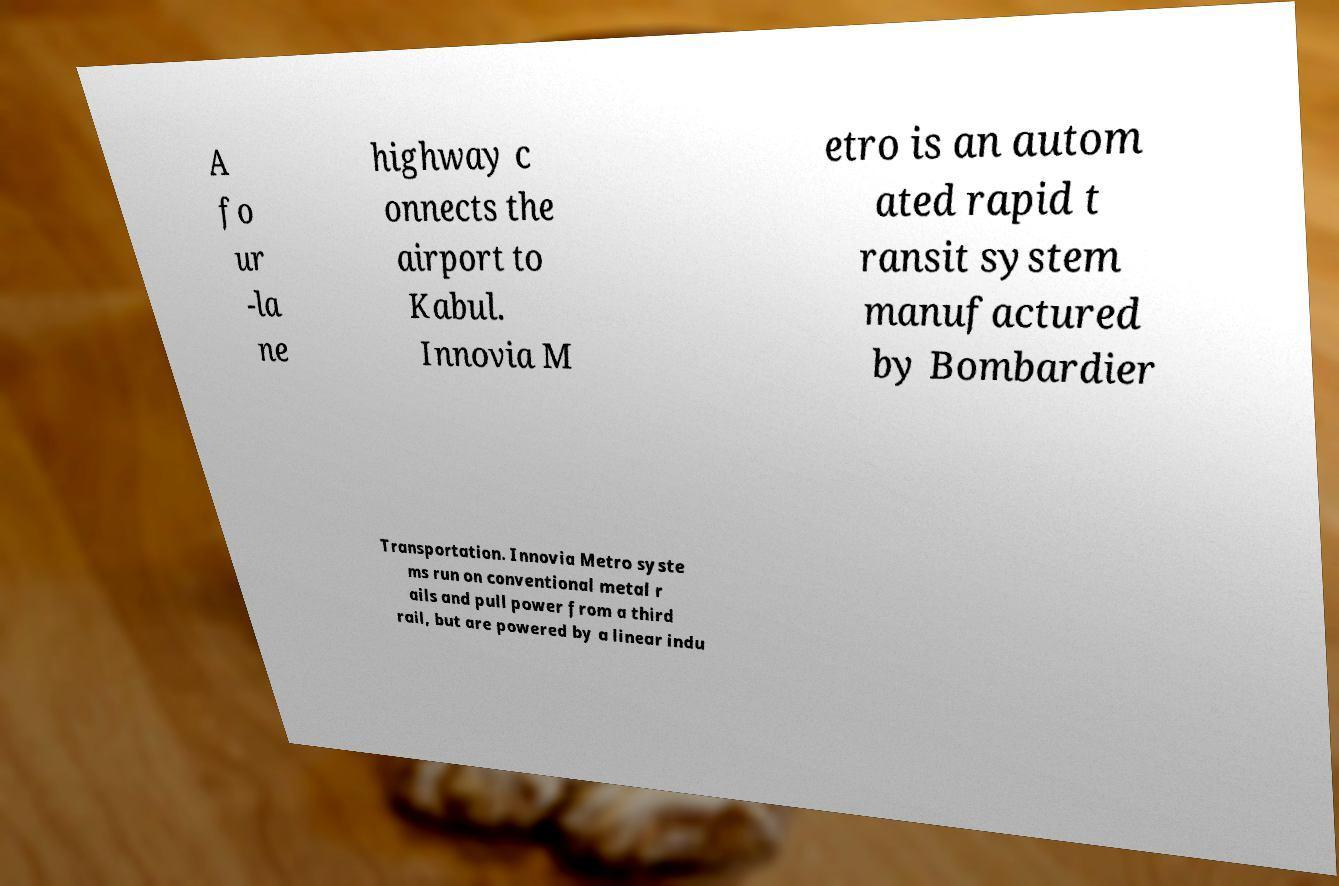For documentation purposes, I need the text within this image transcribed. Could you provide that? A fo ur -la ne highway c onnects the airport to Kabul. Innovia M etro is an autom ated rapid t ransit system manufactured by Bombardier Transportation. Innovia Metro syste ms run on conventional metal r ails and pull power from a third rail, but are powered by a linear indu 